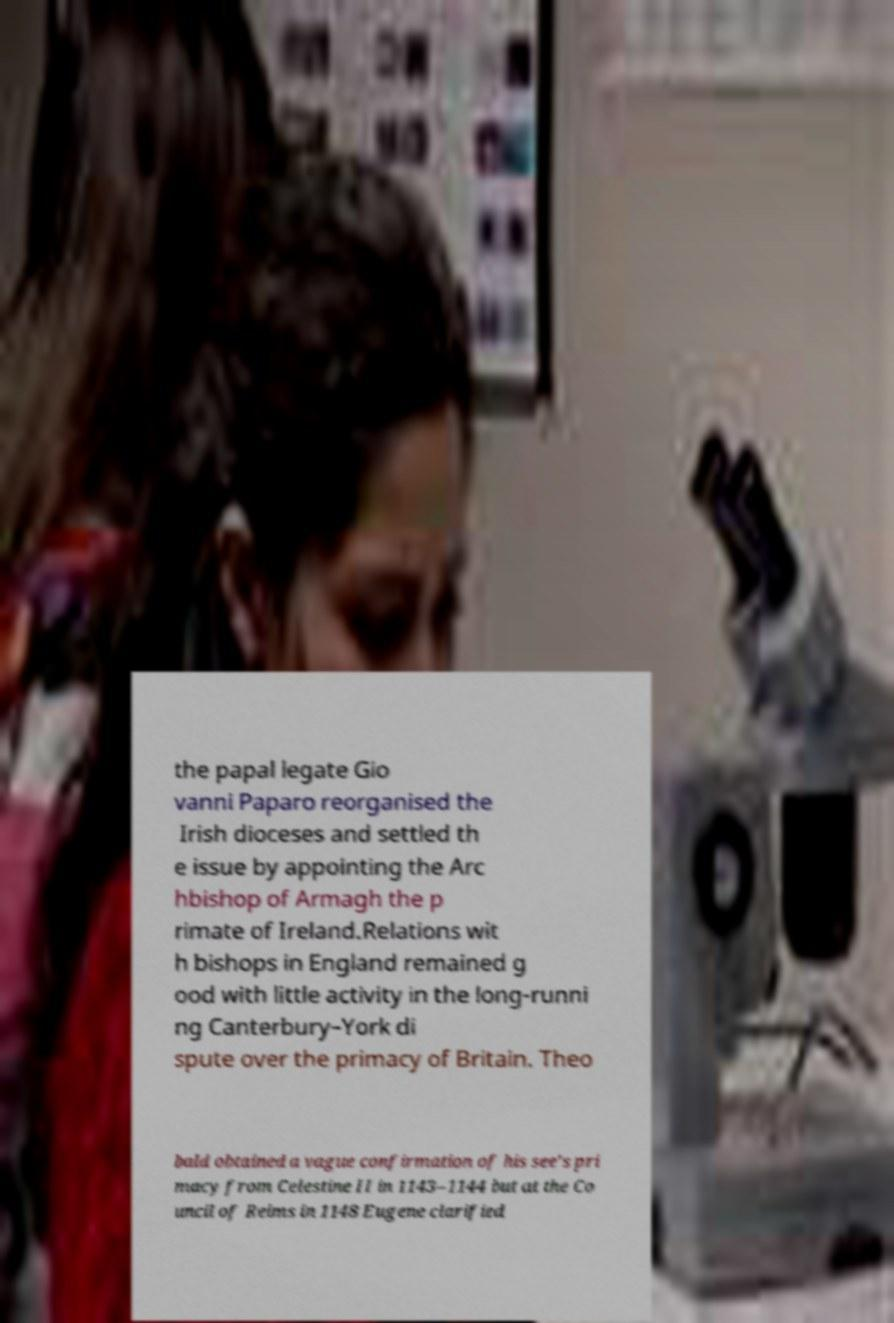Could you extract and type out the text from this image? the papal legate Gio vanni Paparo reorganised the Irish dioceses and settled th e issue by appointing the Arc hbishop of Armagh the p rimate of Ireland.Relations wit h bishops in England remained g ood with little activity in the long-runni ng Canterbury–York di spute over the primacy of Britain. Theo bald obtained a vague confirmation of his see's pri macy from Celestine II in 1143–1144 but at the Co uncil of Reims in 1148 Eugene clarified 